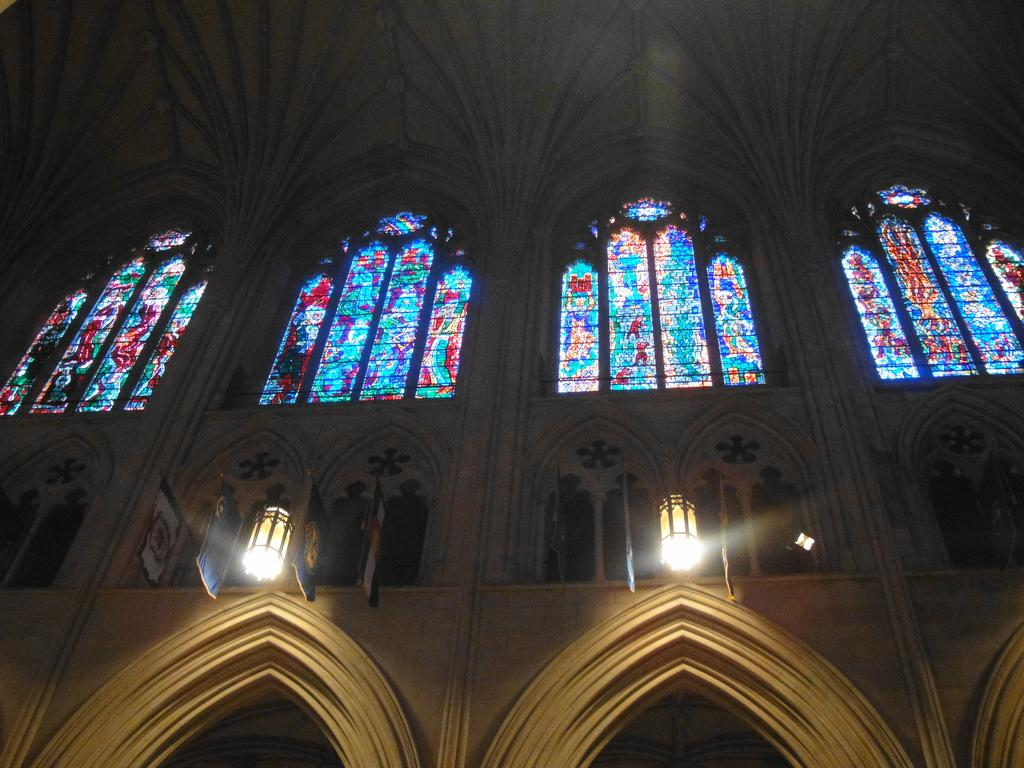What is the main subject of the image? The main subject of the image is an inside part of a mask. Are there any light sources visible in the image? Yes, there are two lights in the walls. What type of government is depicted in the image? There is no government depicted in the image; it is an inside part of a mask with two lights in the walls. How many sisters are present in the image? There are no sisters present in the image; it is an inside part of a mask with two lights in the walls. 